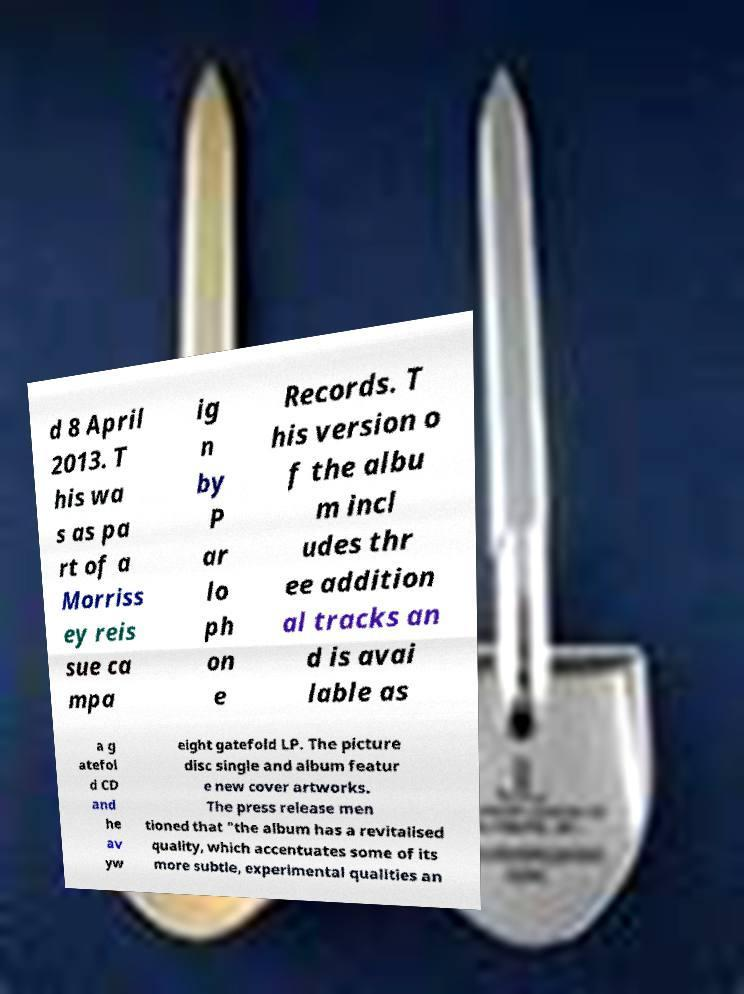I need the written content from this picture converted into text. Can you do that? d 8 April 2013. T his wa s as pa rt of a Morriss ey reis sue ca mpa ig n by P ar lo ph on e Records. T his version o f the albu m incl udes thr ee addition al tracks an d is avai lable as a g atefol d CD and he av yw eight gatefold LP. The picture disc single and album featur e new cover artworks. The press release men tioned that "the album has a revitalised quality, which accentuates some of its more subtle, experimental qualities an 